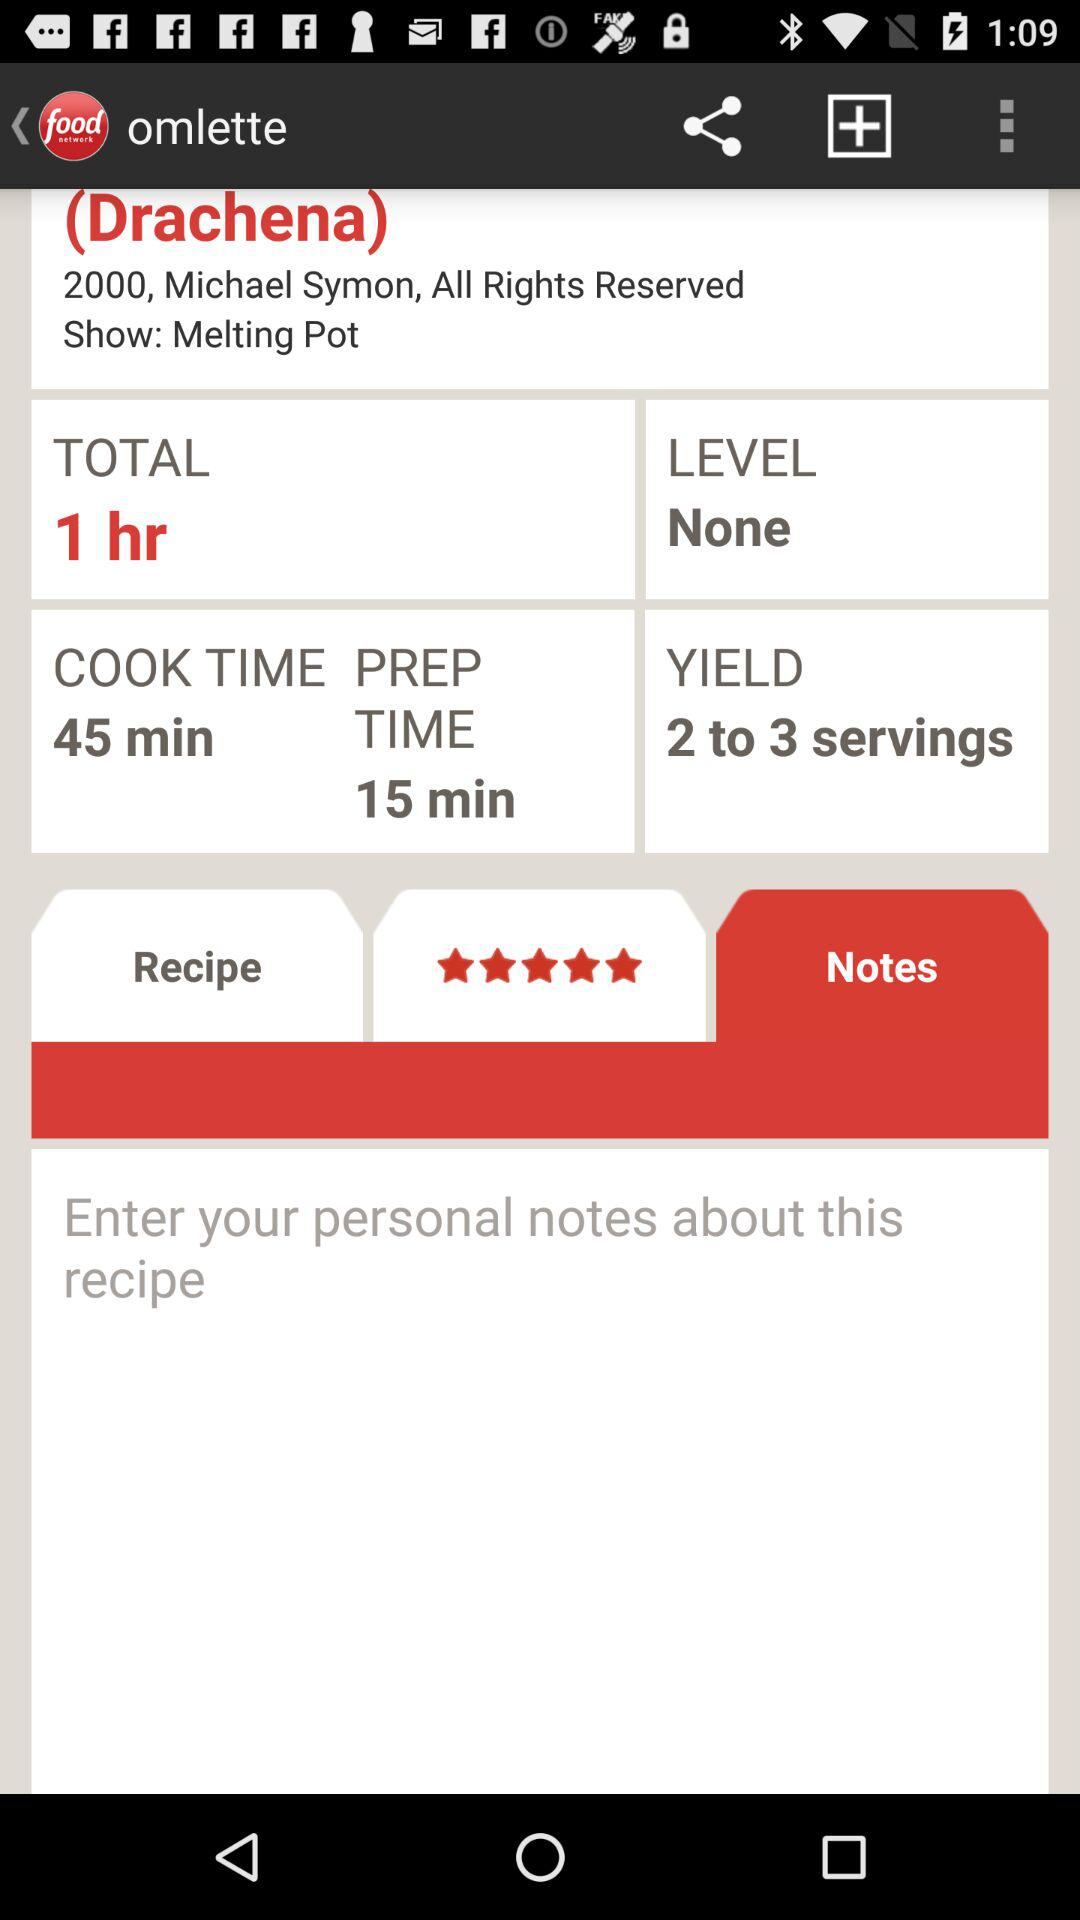What is the rating of the recipe? The rating of the recipe is 5 stars. 